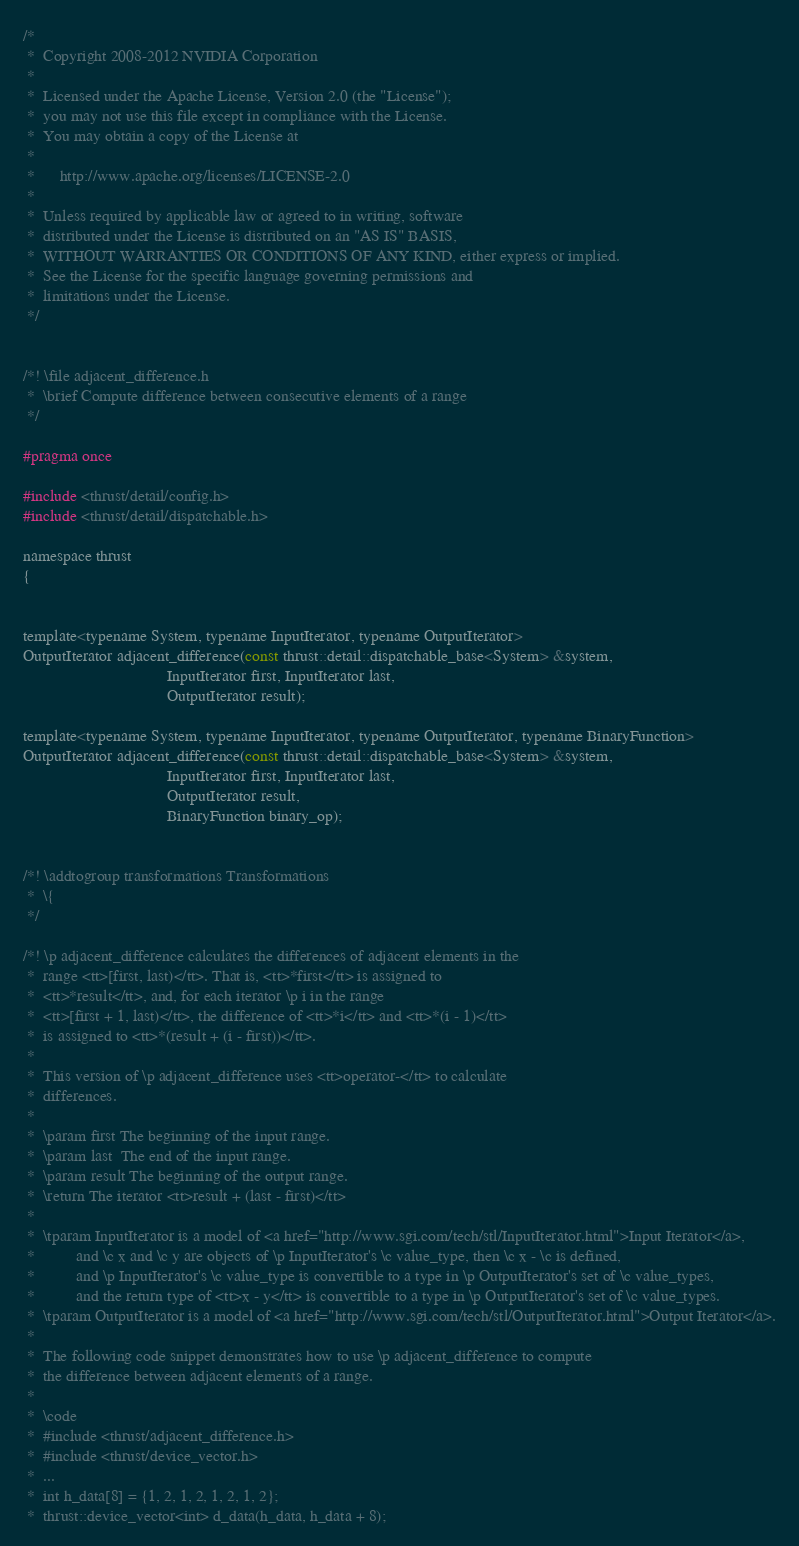<code> <loc_0><loc_0><loc_500><loc_500><_C_>/*
 *  Copyright 2008-2012 NVIDIA Corporation
 *
 *  Licensed under the Apache License, Version 2.0 (the "License");
 *  you may not use this file except in compliance with the License.
 *  You may obtain a copy of the License at
 *
 *      http://www.apache.org/licenses/LICENSE-2.0
 *
 *  Unless required by applicable law or agreed to in writing, software
 *  distributed under the License is distributed on an "AS IS" BASIS,
 *  WITHOUT WARRANTIES OR CONDITIONS OF ANY KIND, either express or implied.
 *  See the License for the specific language governing permissions and
 *  limitations under the License.
 */


/*! \file adjacent_difference.h
 *  \brief Compute difference between consecutive elements of a range
 */

#pragma once

#include <thrust/detail/config.h>
#include <thrust/detail/dispatchable.h>

namespace thrust
{


template<typename System, typename InputIterator, typename OutputIterator>
OutputIterator adjacent_difference(const thrust::detail::dispatchable_base<System> &system,
                                   InputIterator first, InputIterator last, 
                                   OutputIterator result);

template<typename System, typename InputIterator, typename OutputIterator, typename BinaryFunction>
OutputIterator adjacent_difference(const thrust::detail::dispatchable_base<System> &system,
                                   InputIterator first, InputIterator last,
                                   OutputIterator result,
                                   BinaryFunction binary_op);


/*! \addtogroup transformations Transformations
 *  \{
 */

/*! \p adjacent_difference calculates the differences of adjacent elements in the
 *  range <tt>[first, last)</tt>. That is, <tt>*first</tt> is assigned to
 *  <tt>*result</tt>, and, for each iterator \p i in the range
 *  <tt>[first + 1, last)</tt>, the difference of <tt>*i</tt> and <tt>*(i - 1)</tt>
 *  is assigned to <tt>*(result + (i - first))</tt>.
 *
 *  This version of \p adjacent_difference uses <tt>operator-</tt> to calculate
 *  differences.
 *
 *  \param first The beginning of the input range.
 *  \param last  The end of the input range.
 *  \param result The beginning of the output range.
 *  \return The iterator <tt>result + (last - first)</tt>
 *
 *  \tparam InputIterator is a model of <a href="http://www.sgi.com/tech/stl/InputIterator.html">Input Iterator</a>,
 *          and \c x and \c y are objects of \p InputIterator's \c value_type, then \c x - \c is defined,
 *          and \p InputIterator's \c value_type is convertible to a type in \p OutputIterator's set of \c value_types,
 *          and the return type of <tt>x - y</tt> is convertible to a type in \p OutputIterator's set of \c value_types.
 *  \tparam OutputIterator is a model of <a href="http://www.sgi.com/tech/stl/OutputIterator.html">Output Iterator</a>.
 *
 *  The following code snippet demonstrates how to use \p adjacent_difference to compute
 *  the difference between adjacent elements of a range.
 *
 *  \code
 *  #include <thrust/adjacent_difference.h>
 *  #include <thrust/device_vector.h>
 *  ...
 *  int h_data[8] = {1, 2, 1, 2, 1, 2, 1, 2};
 *  thrust::device_vector<int> d_data(h_data, h_data + 8);</code> 